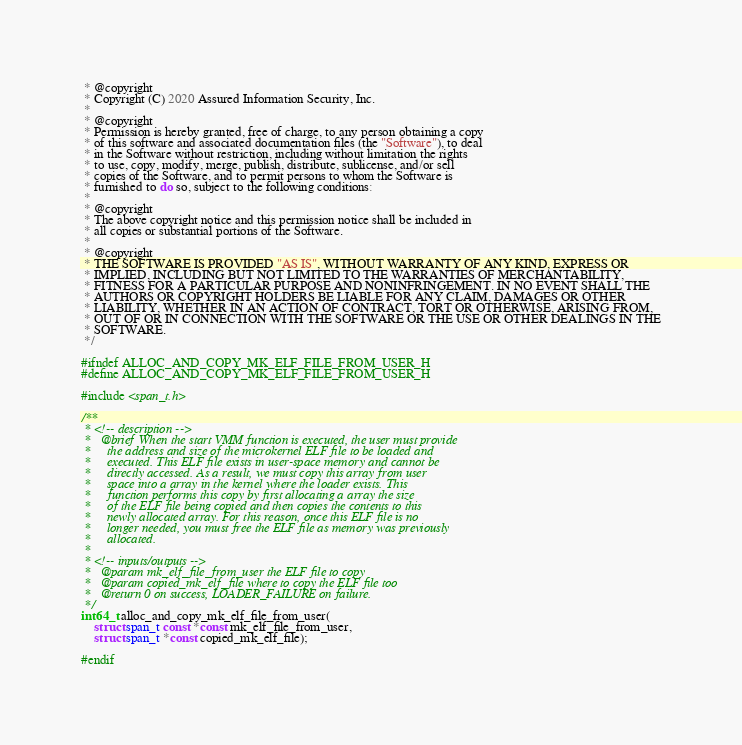Convert code to text. <code><loc_0><loc_0><loc_500><loc_500><_C_> * @copyright
 * Copyright (C) 2020 Assured Information Security, Inc.
 *
 * @copyright
 * Permission is hereby granted, free of charge, to any person obtaining a copy
 * of this software and associated documentation files (the "Software"), to deal
 * in the Software without restriction, including without limitation the rights
 * to use, copy, modify, merge, publish, distribute, sublicense, and/or sell
 * copies of the Software, and to permit persons to whom the Software is
 * furnished to do so, subject to the following conditions:
 *
 * @copyright
 * The above copyright notice and this permission notice shall be included in
 * all copies or substantial portions of the Software.
 *
 * @copyright
 * THE SOFTWARE IS PROVIDED "AS IS", WITHOUT WARRANTY OF ANY KIND, EXPRESS OR
 * IMPLIED, INCLUDING BUT NOT LIMITED TO THE WARRANTIES OF MERCHANTABILITY,
 * FITNESS FOR A PARTICULAR PURPOSE AND NONINFRINGEMENT. IN NO EVENT SHALL THE
 * AUTHORS OR COPYRIGHT HOLDERS BE LIABLE FOR ANY CLAIM, DAMAGES OR OTHER
 * LIABILITY, WHETHER IN AN ACTION OF CONTRACT, TORT OR OTHERWISE, ARISING FROM,
 * OUT OF OR IN CONNECTION WITH THE SOFTWARE OR THE USE OR OTHER DEALINGS IN THE
 * SOFTWARE.
 */

#ifndef ALLOC_AND_COPY_MK_ELF_FILE_FROM_USER_H
#define ALLOC_AND_COPY_MK_ELF_FILE_FROM_USER_H

#include <span_t.h>

/**
 * <!-- description -->
 *   @brief When the start VMM function is executed, the user must provide
 *     the address and size of the microkernel ELF file to be loaded and
 *     executed. This ELF file exists in user-space memory and cannot be
 *     directly accessed. As a result, we must copy this array from user
 *     space into a array in the kernel where the loader exists. This
 *     function performs this copy by first allocating a array the size
 *     of the ELF file being copied and then copies the contents to this
 *     newly allocated array. For this reason, once this ELF file is no
 *     longer needed, you must free the ELF file as memory was previously
 *     allocated.
 *
 * <!-- inputs/outputs -->
 *   @param mk_elf_file_from_user the ELF file to copy
 *   @param copied_mk_elf_file where to copy the ELF file too
 *   @return 0 on success, LOADER_FAILURE on failure.
 */
int64_t alloc_and_copy_mk_elf_file_from_user(
    struct span_t const *const mk_elf_file_from_user,
    struct span_t *const copied_mk_elf_file);

#endif
</code> 